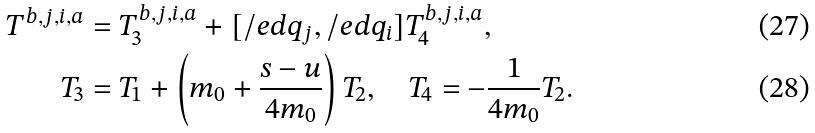Convert formula to latex. <formula><loc_0><loc_0><loc_500><loc_500>T ^ { b , j , i , a } & = T _ { 3 } ^ { b , j , i , a } + [ \slash e d { q } _ { j } , \slash e d { q } _ { i } ] T _ { 4 } ^ { b , j , i , a } , \\ T _ { 3 } & = T _ { 1 } + \left ( m _ { 0 } + \frac { s - u } { 4 m _ { 0 } } \right ) T _ { 2 } , \quad T _ { 4 } = - \frac { 1 } { 4 m _ { 0 } } T _ { 2 } .</formula> 